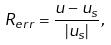<formula> <loc_0><loc_0><loc_500><loc_500>R _ { e r r } = \frac { u - u _ { s } } { | u _ { s } | } ,</formula> 